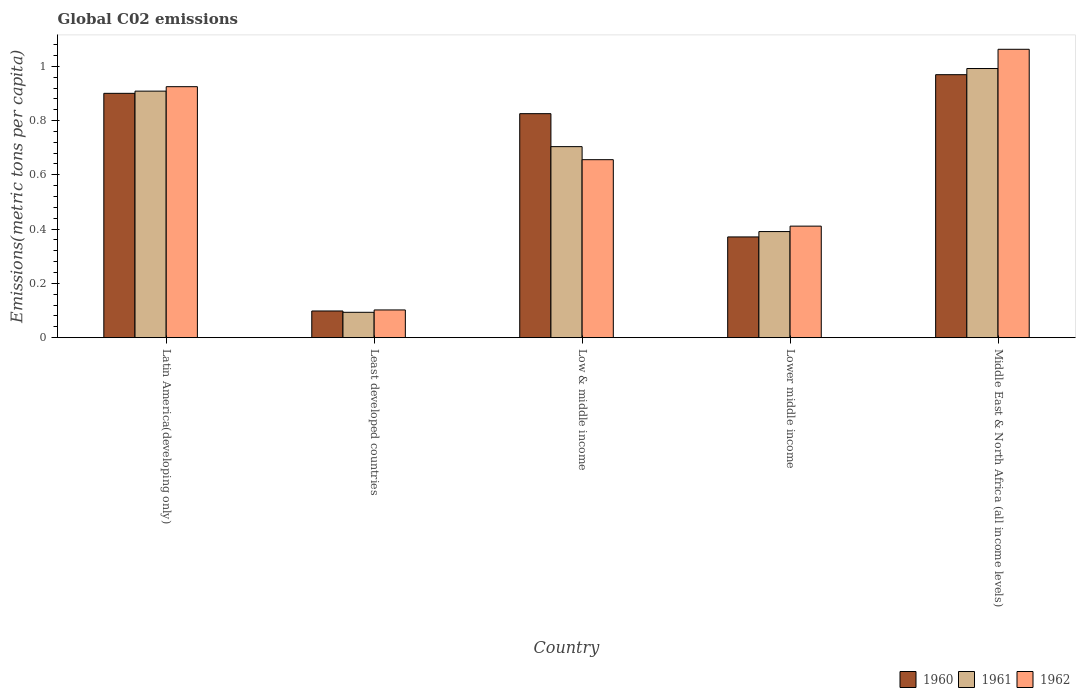How many groups of bars are there?
Offer a very short reply. 5. Are the number of bars on each tick of the X-axis equal?
Ensure brevity in your answer.  Yes. How many bars are there on the 2nd tick from the left?
Provide a succinct answer. 3. What is the label of the 5th group of bars from the left?
Offer a terse response. Middle East & North Africa (all income levels). In how many cases, is the number of bars for a given country not equal to the number of legend labels?
Your response must be concise. 0. What is the amount of CO2 emitted in in 1960 in Latin America(developing only)?
Provide a short and direct response. 0.9. Across all countries, what is the maximum amount of CO2 emitted in in 1961?
Provide a succinct answer. 0.99. Across all countries, what is the minimum amount of CO2 emitted in in 1962?
Offer a terse response. 0.1. In which country was the amount of CO2 emitted in in 1960 maximum?
Make the answer very short. Middle East & North Africa (all income levels). In which country was the amount of CO2 emitted in in 1961 minimum?
Your response must be concise. Least developed countries. What is the total amount of CO2 emitted in in 1960 in the graph?
Give a very brief answer. 3.16. What is the difference between the amount of CO2 emitted in in 1962 in Latin America(developing only) and that in Low & middle income?
Give a very brief answer. 0.27. What is the difference between the amount of CO2 emitted in in 1960 in Lower middle income and the amount of CO2 emitted in in 1961 in Middle East & North Africa (all income levels)?
Offer a very short reply. -0.62. What is the average amount of CO2 emitted in in 1961 per country?
Your answer should be very brief. 0.62. What is the difference between the amount of CO2 emitted in of/in 1962 and amount of CO2 emitted in of/in 1961 in Least developed countries?
Make the answer very short. 0.01. What is the ratio of the amount of CO2 emitted in in 1960 in Lower middle income to that in Middle East & North Africa (all income levels)?
Your answer should be compact. 0.38. What is the difference between the highest and the second highest amount of CO2 emitted in in 1960?
Keep it short and to the point. 0.07. What is the difference between the highest and the lowest amount of CO2 emitted in in 1961?
Your answer should be very brief. 0.9. Is the sum of the amount of CO2 emitted in in 1960 in Latin America(developing only) and Low & middle income greater than the maximum amount of CO2 emitted in in 1961 across all countries?
Make the answer very short. Yes. What does the 1st bar from the left in Latin America(developing only) represents?
Provide a succinct answer. 1960. What does the 2nd bar from the right in Lower middle income represents?
Offer a terse response. 1961. Is it the case that in every country, the sum of the amount of CO2 emitted in in 1962 and amount of CO2 emitted in in 1960 is greater than the amount of CO2 emitted in in 1961?
Ensure brevity in your answer.  Yes. Where does the legend appear in the graph?
Provide a succinct answer. Bottom right. What is the title of the graph?
Give a very brief answer. Global C02 emissions. Does "2002" appear as one of the legend labels in the graph?
Your answer should be very brief. No. What is the label or title of the X-axis?
Provide a short and direct response. Country. What is the label or title of the Y-axis?
Offer a terse response. Emissions(metric tons per capita). What is the Emissions(metric tons per capita) of 1960 in Latin America(developing only)?
Your response must be concise. 0.9. What is the Emissions(metric tons per capita) of 1961 in Latin America(developing only)?
Offer a very short reply. 0.91. What is the Emissions(metric tons per capita) in 1962 in Latin America(developing only)?
Make the answer very short. 0.92. What is the Emissions(metric tons per capita) of 1960 in Least developed countries?
Offer a terse response. 0.1. What is the Emissions(metric tons per capita) in 1961 in Least developed countries?
Provide a short and direct response. 0.09. What is the Emissions(metric tons per capita) of 1962 in Least developed countries?
Offer a terse response. 0.1. What is the Emissions(metric tons per capita) in 1960 in Low & middle income?
Ensure brevity in your answer.  0.83. What is the Emissions(metric tons per capita) of 1961 in Low & middle income?
Ensure brevity in your answer.  0.7. What is the Emissions(metric tons per capita) in 1962 in Low & middle income?
Your response must be concise. 0.66. What is the Emissions(metric tons per capita) in 1960 in Lower middle income?
Keep it short and to the point. 0.37. What is the Emissions(metric tons per capita) of 1961 in Lower middle income?
Your answer should be very brief. 0.39. What is the Emissions(metric tons per capita) in 1962 in Lower middle income?
Provide a short and direct response. 0.41. What is the Emissions(metric tons per capita) of 1960 in Middle East & North Africa (all income levels)?
Make the answer very short. 0.97. What is the Emissions(metric tons per capita) in 1961 in Middle East & North Africa (all income levels)?
Your response must be concise. 0.99. What is the Emissions(metric tons per capita) in 1962 in Middle East & North Africa (all income levels)?
Keep it short and to the point. 1.06. Across all countries, what is the maximum Emissions(metric tons per capita) of 1960?
Give a very brief answer. 0.97. Across all countries, what is the maximum Emissions(metric tons per capita) of 1961?
Keep it short and to the point. 0.99. Across all countries, what is the maximum Emissions(metric tons per capita) of 1962?
Offer a terse response. 1.06. Across all countries, what is the minimum Emissions(metric tons per capita) of 1960?
Your response must be concise. 0.1. Across all countries, what is the minimum Emissions(metric tons per capita) in 1961?
Offer a terse response. 0.09. Across all countries, what is the minimum Emissions(metric tons per capita) in 1962?
Offer a very short reply. 0.1. What is the total Emissions(metric tons per capita) of 1960 in the graph?
Provide a succinct answer. 3.16. What is the total Emissions(metric tons per capita) of 1961 in the graph?
Ensure brevity in your answer.  3.09. What is the total Emissions(metric tons per capita) in 1962 in the graph?
Provide a succinct answer. 3.16. What is the difference between the Emissions(metric tons per capita) in 1960 in Latin America(developing only) and that in Least developed countries?
Make the answer very short. 0.8. What is the difference between the Emissions(metric tons per capita) in 1961 in Latin America(developing only) and that in Least developed countries?
Keep it short and to the point. 0.81. What is the difference between the Emissions(metric tons per capita) of 1962 in Latin America(developing only) and that in Least developed countries?
Keep it short and to the point. 0.82. What is the difference between the Emissions(metric tons per capita) of 1960 in Latin America(developing only) and that in Low & middle income?
Give a very brief answer. 0.07. What is the difference between the Emissions(metric tons per capita) in 1961 in Latin America(developing only) and that in Low & middle income?
Provide a short and direct response. 0.2. What is the difference between the Emissions(metric tons per capita) in 1962 in Latin America(developing only) and that in Low & middle income?
Provide a short and direct response. 0.27. What is the difference between the Emissions(metric tons per capita) of 1960 in Latin America(developing only) and that in Lower middle income?
Your answer should be very brief. 0.53. What is the difference between the Emissions(metric tons per capita) of 1961 in Latin America(developing only) and that in Lower middle income?
Offer a terse response. 0.52. What is the difference between the Emissions(metric tons per capita) of 1962 in Latin America(developing only) and that in Lower middle income?
Give a very brief answer. 0.51. What is the difference between the Emissions(metric tons per capita) of 1960 in Latin America(developing only) and that in Middle East & North Africa (all income levels)?
Provide a succinct answer. -0.07. What is the difference between the Emissions(metric tons per capita) of 1961 in Latin America(developing only) and that in Middle East & North Africa (all income levels)?
Your answer should be compact. -0.08. What is the difference between the Emissions(metric tons per capita) in 1962 in Latin America(developing only) and that in Middle East & North Africa (all income levels)?
Your answer should be compact. -0.14. What is the difference between the Emissions(metric tons per capita) in 1960 in Least developed countries and that in Low & middle income?
Your response must be concise. -0.73. What is the difference between the Emissions(metric tons per capita) in 1961 in Least developed countries and that in Low & middle income?
Offer a very short reply. -0.61. What is the difference between the Emissions(metric tons per capita) in 1962 in Least developed countries and that in Low & middle income?
Provide a succinct answer. -0.55. What is the difference between the Emissions(metric tons per capita) of 1960 in Least developed countries and that in Lower middle income?
Provide a short and direct response. -0.27. What is the difference between the Emissions(metric tons per capita) in 1961 in Least developed countries and that in Lower middle income?
Provide a short and direct response. -0.3. What is the difference between the Emissions(metric tons per capita) of 1962 in Least developed countries and that in Lower middle income?
Provide a succinct answer. -0.31. What is the difference between the Emissions(metric tons per capita) of 1960 in Least developed countries and that in Middle East & North Africa (all income levels)?
Give a very brief answer. -0.87. What is the difference between the Emissions(metric tons per capita) in 1961 in Least developed countries and that in Middle East & North Africa (all income levels)?
Offer a very short reply. -0.9. What is the difference between the Emissions(metric tons per capita) of 1962 in Least developed countries and that in Middle East & North Africa (all income levels)?
Give a very brief answer. -0.96. What is the difference between the Emissions(metric tons per capita) in 1960 in Low & middle income and that in Lower middle income?
Give a very brief answer. 0.45. What is the difference between the Emissions(metric tons per capita) of 1961 in Low & middle income and that in Lower middle income?
Ensure brevity in your answer.  0.31. What is the difference between the Emissions(metric tons per capita) in 1962 in Low & middle income and that in Lower middle income?
Your answer should be compact. 0.24. What is the difference between the Emissions(metric tons per capita) of 1960 in Low & middle income and that in Middle East & North Africa (all income levels)?
Your answer should be compact. -0.14. What is the difference between the Emissions(metric tons per capita) of 1961 in Low & middle income and that in Middle East & North Africa (all income levels)?
Your answer should be compact. -0.29. What is the difference between the Emissions(metric tons per capita) of 1962 in Low & middle income and that in Middle East & North Africa (all income levels)?
Your answer should be very brief. -0.41. What is the difference between the Emissions(metric tons per capita) in 1960 in Lower middle income and that in Middle East & North Africa (all income levels)?
Offer a terse response. -0.6. What is the difference between the Emissions(metric tons per capita) in 1961 in Lower middle income and that in Middle East & North Africa (all income levels)?
Offer a very short reply. -0.6. What is the difference between the Emissions(metric tons per capita) in 1962 in Lower middle income and that in Middle East & North Africa (all income levels)?
Your answer should be very brief. -0.65. What is the difference between the Emissions(metric tons per capita) of 1960 in Latin America(developing only) and the Emissions(metric tons per capita) of 1961 in Least developed countries?
Your answer should be compact. 0.81. What is the difference between the Emissions(metric tons per capita) of 1960 in Latin America(developing only) and the Emissions(metric tons per capita) of 1962 in Least developed countries?
Make the answer very short. 0.8. What is the difference between the Emissions(metric tons per capita) in 1961 in Latin America(developing only) and the Emissions(metric tons per capita) in 1962 in Least developed countries?
Provide a short and direct response. 0.81. What is the difference between the Emissions(metric tons per capita) of 1960 in Latin America(developing only) and the Emissions(metric tons per capita) of 1961 in Low & middle income?
Give a very brief answer. 0.2. What is the difference between the Emissions(metric tons per capita) in 1960 in Latin America(developing only) and the Emissions(metric tons per capita) in 1962 in Low & middle income?
Your answer should be very brief. 0.24. What is the difference between the Emissions(metric tons per capita) of 1961 in Latin America(developing only) and the Emissions(metric tons per capita) of 1962 in Low & middle income?
Make the answer very short. 0.25. What is the difference between the Emissions(metric tons per capita) in 1960 in Latin America(developing only) and the Emissions(metric tons per capita) in 1961 in Lower middle income?
Offer a very short reply. 0.51. What is the difference between the Emissions(metric tons per capita) of 1960 in Latin America(developing only) and the Emissions(metric tons per capita) of 1962 in Lower middle income?
Keep it short and to the point. 0.49. What is the difference between the Emissions(metric tons per capita) of 1961 in Latin America(developing only) and the Emissions(metric tons per capita) of 1962 in Lower middle income?
Offer a very short reply. 0.5. What is the difference between the Emissions(metric tons per capita) of 1960 in Latin America(developing only) and the Emissions(metric tons per capita) of 1961 in Middle East & North Africa (all income levels)?
Provide a short and direct response. -0.09. What is the difference between the Emissions(metric tons per capita) in 1960 in Latin America(developing only) and the Emissions(metric tons per capita) in 1962 in Middle East & North Africa (all income levels)?
Make the answer very short. -0.16. What is the difference between the Emissions(metric tons per capita) of 1961 in Latin America(developing only) and the Emissions(metric tons per capita) of 1962 in Middle East & North Africa (all income levels)?
Make the answer very short. -0.15. What is the difference between the Emissions(metric tons per capita) of 1960 in Least developed countries and the Emissions(metric tons per capita) of 1961 in Low & middle income?
Your answer should be compact. -0.61. What is the difference between the Emissions(metric tons per capita) of 1960 in Least developed countries and the Emissions(metric tons per capita) of 1962 in Low & middle income?
Your answer should be compact. -0.56. What is the difference between the Emissions(metric tons per capita) of 1961 in Least developed countries and the Emissions(metric tons per capita) of 1962 in Low & middle income?
Your answer should be very brief. -0.56. What is the difference between the Emissions(metric tons per capita) in 1960 in Least developed countries and the Emissions(metric tons per capita) in 1961 in Lower middle income?
Your answer should be compact. -0.29. What is the difference between the Emissions(metric tons per capita) of 1960 in Least developed countries and the Emissions(metric tons per capita) of 1962 in Lower middle income?
Provide a short and direct response. -0.31. What is the difference between the Emissions(metric tons per capita) of 1961 in Least developed countries and the Emissions(metric tons per capita) of 1962 in Lower middle income?
Provide a short and direct response. -0.32. What is the difference between the Emissions(metric tons per capita) of 1960 in Least developed countries and the Emissions(metric tons per capita) of 1961 in Middle East & North Africa (all income levels)?
Give a very brief answer. -0.89. What is the difference between the Emissions(metric tons per capita) in 1960 in Least developed countries and the Emissions(metric tons per capita) in 1962 in Middle East & North Africa (all income levels)?
Provide a succinct answer. -0.96. What is the difference between the Emissions(metric tons per capita) in 1961 in Least developed countries and the Emissions(metric tons per capita) in 1962 in Middle East & North Africa (all income levels)?
Make the answer very short. -0.97. What is the difference between the Emissions(metric tons per capita) of 1960 in Low & middle income and the Emissions(metric tons per capita) of 1961 in Lower middle income?
Offer a terse response. 0.43. What is the difference between the Emissions(metric tons per capita) in 1960 in Low & middle income and the Emissions(metric tons per capita) in 1962 in Lower middle income?
Your response must be concise. 0.41. What is the difference between the Emissions(metric tons per capita) in 1961 in Low & middle income and the Emissions(metric tons per capita) in 1962 in Lower middle income?
Provide a succinct answer. 0.29. What is the difference between the Emissions(metric tons per capita) in 1960 in Low & middle income and the Emissions(metric tons per capita) in 1961 in Middle East & North Africa (all income levels)?
Provide a succinct answer. -0.17. What is the difference between the Emissions(metric tons per capita) of 1960 in Low & middle income and the Emissions(metric tons per capita) of 1962 in Middle East & North Africa (all income levels)?
Your answer should be very brief. -0.24. What is the difference between the Emissions(metric tons per capita) in 1961 in Low & middle income and the Emissions(metric tons per capita) in 1962 in Middle East & North Africa (all income levels)?
Your response must be concise. -0.36. What is the difference between the Emissions(metric tons per capita) of 1960 in Lower middle income and the Emissions(metric tons per capita) of 1961 in Middle East & North Africa (all income levels)?
Your response must be concise. -0.62. What is the difference between the Emissions(metric tons per capita) in 1960 in Lower middle income and the Emissions(metric tons per capita) in 1962 in Middle East & North Africa (all income levels)?
Keep it short and to the point. -0.69. What is the difference between the Emissions(metric tons per capita) in 1961 in Lower middle income and the Emissions(metric tons per capita) in 1962 in Middle East & North Africa (all income levels)?
Give a very brief answer. -0.67. What is the average Emissions(metric tons per capita) in 1960 per country?
Ensure brevity in your answer.  0.63. What is the average Emissions(metric tons per capita) of 1961 per country?
Provide a succinct answer. 0.62. What is the average Emissions(metric tons per capita) of 1962 per country?
Provide a short and direct response. 0.63. What is the difference between the Emissions(metric tons per capita) in 1960 and Emissions(metric tons per capita) in 1961 in Latin America(developing only)?
Your response must be concise. -0.01. What is the difference between the Emissions(metric tons per capita) in 1960 and Emissions(metric tons per capita) in 1962 in Latin America(developing only)?
Your answer should be very brief. -0.02. What is the difference between the Emissions(metric tons per capita) in 1961 and Emissions(metric tons per capita) in 1962 in Latin America(developing only)?
Your response must be concise. -0.02. What is the difference between the Emissions(metric tons per capita) in 1960 and Emissions(metric tons per capita) in 1961 in Least developed countries?
Your answer should be compact. 0. What is the difference between the Emissions(metric tons per capita) in 1960 and Emissions(metric tons per capita) in 1962 in Least developed countries?
Offer a very short reply. -0. What is the difference between the Emissions(metric tons per capita) of 1961 and Emissions(metric tons per capita) of 1962 in Least developed countries?
Your answer should be compact. -0.01. What is the difference between the Emissions(metric tons per capita) of 1960 and Emissions(metric tons per capita) of 1961 in Low & middle income?
Ensure brevity in your answer.  0.12. What is the difference between the Emissions(metric tons per capita) in 1960 and Emissions(metric tons per capita) in 1962 in Low & middle income?
Keep it short and to the point. 0.17. What is the difference between the Emissions(metric tons per capita) in 1961 and Emissions(metric tons per capita) in 1962 in Low & middle income?
Provide a short and direct response. 0.05. What is the difference between the Emissions(metric tons per capita) in 1960 and Emissions(metric tons per capita) in 1961 in Lower middle income?
Your answer should be compact. -0.02. What is the difference between the Emissions(metric tons per capita) of 1960 and Emissions(metric tons per capita) of 1962 in Lower middle income?
Offer a very short reply. -0.04. What is the difference between the Emissions(metric tons per capita) of 1961 and Emissions(metric tons per capita) of 1962 in Lower middle income?
Your response must be concise. -0.02. What is the difference between the Emissions(metric tons per capita) of 1960 and Emissions(metric tons per capita) of 1961 in Middle East & North Africa (all income levels)?
Give a very brief answer. -0.02. What is the difference between the Emissions(metric tons per capita) in 1960 and Emissions(metric tons per capita) in 1962 in Middle East & North Africa (all income levels)?
Your answer should be compact. -0.09. What is the difference between the Emissions(metric tons per capita) in 1961 and Emissions(metric tons per capita) in 1962 in Middle East & North Africa (all income levels)?
Keep it short and to the point. -0.07. What is the ratio of the Emissions(metric tons per capita) of 1960 in Latin America(developing only) to that in Least developed countries?
Provide a succinct answer. 9.16. What is the ratio of the Emissions(metric tons per capita) of 1961 in Latin America(developing only) to that in Least developed countries?
Keep it short and to the point. 9.72. What is the ratio of the Emissions(metric tons per capita) of 1962 in Latin America(developing only) to that in Least developed countries?
Your answer should be compact. 9.05. What is the ratio of the Emissions(metric tons per capita) in 1960 in Latin America(developing only) to that in Low & middle income?
Give a very brief answer. 1.09. What is the ratio of the Emissions(metric tons per capita) in 1961 in Latin America(developing only) to that in Low & middle income?
Give a very brief answer. 1.29. What is the ratio of the Emissions(metric tons per capita) of 1962 in Latin America(developing only) to that in Low & middle income?
Keep it short and to the point. 1.41. What is the ratio of the Emissions(metric tons per capita) in 1960 in Latin America(developing only) to that in Lower middle income?
Ensure brevity in your answer.  2.43. What is the ratio of the Emissions(metric tons per capita) in 1961 in Latin America(developing only) to that in Lower middle income?
Your answer should be compact. 2.32. What is the ratio of the Emissions(metric tons per capita) of 1962 in Latin America(developing only) to that in Lower middle income?
Keep it short and to the point. 2.25. What is the ratio of the Emissions(metric tons per capita) of 1960 in Latin America(developing only) to that in Middle East & North Africa (all income levels)?
Your answer should be compact. 0.93. What is the ratio of the Emissions(metric tons per capita) of 1961 in Latin America(developing only) to that in Middle East & North Africa (all income levels)?
Ensure brevity in your answer.  0.92. What is the ratio of the Emissions(metric tons per capita) of 1962 in Latin America(developing only) to that in Middle East & North Africa (all income levels)?
Give a very brief answer. 0.87. What is the ratio of the Emissions(metric tons per capita) in 1960 in Least developed countries to that in Low & middle income?
Your answer should be compact. 0.12. What is the ratio of the Emissions(metric tons per capita) of 1961 in Least developed countries to that in Low & middle income?
Keep it short and to the point. 0.13. What is the ratio of the Emissions(metric tons per capita) in 1962 in Least developed countries to that in Low & middle income?
Offer a very short reply. 0.16. What is the ratio of the Emissions(metric tons per capita) of 1960 in Least developed countries to that in Lower middle income?
Your answer should be compact. 0.26. What is the ratio of the Emissions(metric tons per capita) of 1961 in Least developed countries to that in Lower middle income?
Offer a terse response. 0.24. What is the ratio of the Emissions(metric tons per capita) of 1962 in Least developed countries to that in Lower middle income?
Make the answer very short. 0.25. What is the ratio of the Emissions(metric tons per capita) of 1960 in Least developed countries to that in Middle East & North Africa (all income levels)?
Offer a very short reply. 0.1. What is the ratio of the Emissions(metric tons per capita) of 1961 in Least developed countries to that in Middle East & North Africa (all income levels)?
Ensure brevity in your answer.  0.09. What is the ratio of the Emissions(metric tons per capita) in 1962 in Least developed countries to that in Middle East & North Africa (all income levels)?
Your answer should be very brief. 0.1. What is the ratio of the Emissions(metric tons per capita) of 1960 in Low & middle income to that in Lower middle income?
Offer a very short reply. 2.22. What is the ratio of the Emissions(metric tons per capita) in 1961 in Low & middle income to that in Lower middle income?
Offer a very short reply. 1.8. What is the ratio of the Emissions(metric tons per capita) of 1962 in Low & middle income to that in Lower middle income?
Provide a short and direct response. 1.6. What is the ratio of the Emissions(metric tons per capita) of 1960 in Low & middle income to that in Middle East & North Africa (all income levels)?
Give a very brief answer. 0.85. What is the ratio of the Emissions(metric tons per capita) of 1961 in Low & middle income to that in Middle East & North Africa (all income levels)?
Your answer should be compact. 0.71. What is the ratio of the Emissions(metric tons per capita) in 1962 in Low & middle income to that in Middle East & North Africa (all income levels)?
Keep it short and to the point. 0.62. What is the ratio of the Emissions(metric tons per capita) of 1960 in Lower middle income to that in Middle East & North Africa (all income levels)?
Offer a terse response. 0.38. What is the ratio of the Emissions(metric tons per capita) of 1961 in Lower middle income to that in Middle East & North Africa (all income levels)?
Provide a short and direct response. 0.39. What is the ratio of the Emissions(metric tons per capita) in 1962 in Lower middle income to that in Middle East & North Africa (all income levels)?
Your answer should be very brief. 0.39. What is the difference between the highest and the second highest Emissions(metric tons per capita) of 1960?
Offer a very short reply. 0.07. What is the difference between the highest and the second highest Emissions(metric tons per capita) of 1961?
Give a very brief answer. 0.08. What is the difference between the highest and the second highest Emissions(metric tons per capita) in 1962?
Make the answer very short. 0.14. What is the difference between the highest and the lowest Emissions(metric tons per capita) of 1960?
Provide a short and direct response. 0.87. What is the difference between the highest and the lowest Emissions(metric tons per capita) in 1961?
Provide a short and direct response. 0.9. What is the difference between the highest and the lowest Emissions(metric tons per capita) in 1962?
Your answer should be compact. 0.96. 